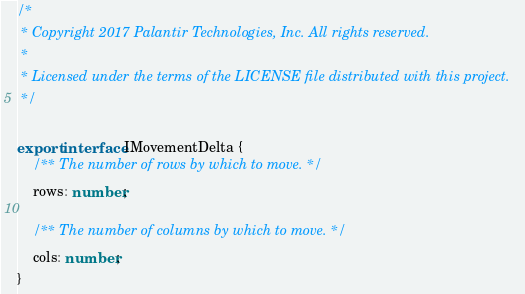<code> <loc_0><loc_0><loc_500><loc_500><_TypeScript_>/*
 * Copyright 2017 Palantir Technologies, Inc. All rights reserved.
 *
 * Licensed under the terms of the LICENSE file distributed with this project.
 */

export interface IMovementDelta {
    /** The number of rows by which to move. */
    rows: number;

    /** The number of columns by which to move. */
    cols: number;
}
</code> 